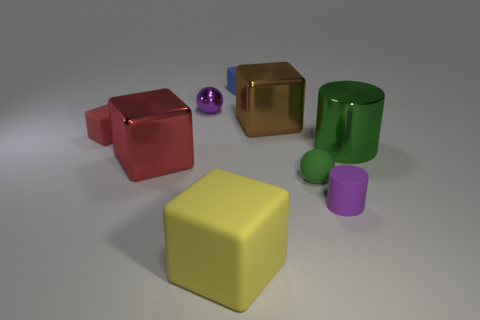Subtract all blue cubes. How many cubes are left? 4 Subtract all red shiny cubes. How many cubes are left? 4 Subtract all cyan blocks. Subtract all gray cylinders. How many blocks are left? 5 Add 1 large yellow rubber cubes. How many objects exist? 10 Subtract all balls. How many objects are left? 7 Subtract 1 purple spheres. How many objects are left? 8 Subtract all big yellow objects. Subtract all matte balls. How many objects are left? 7 Add 4 tiny purple objects. How many tiny purple objects are left? 6 Add 8 gray rubber cylinders. How many gray rubber cylinders exist? 8 